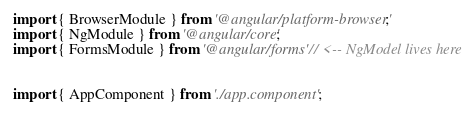<code> <loc_0><loc_0><loc_500><loc_500><_TypeScript_>import { BrowserModule } from '@angular/platform-browser';
import { NgModule } from '@angular/core';
import { FormsModule } from '@angular/forms' // <-- NgModel lives here


import { AppComponent } from './app.component';</code> 